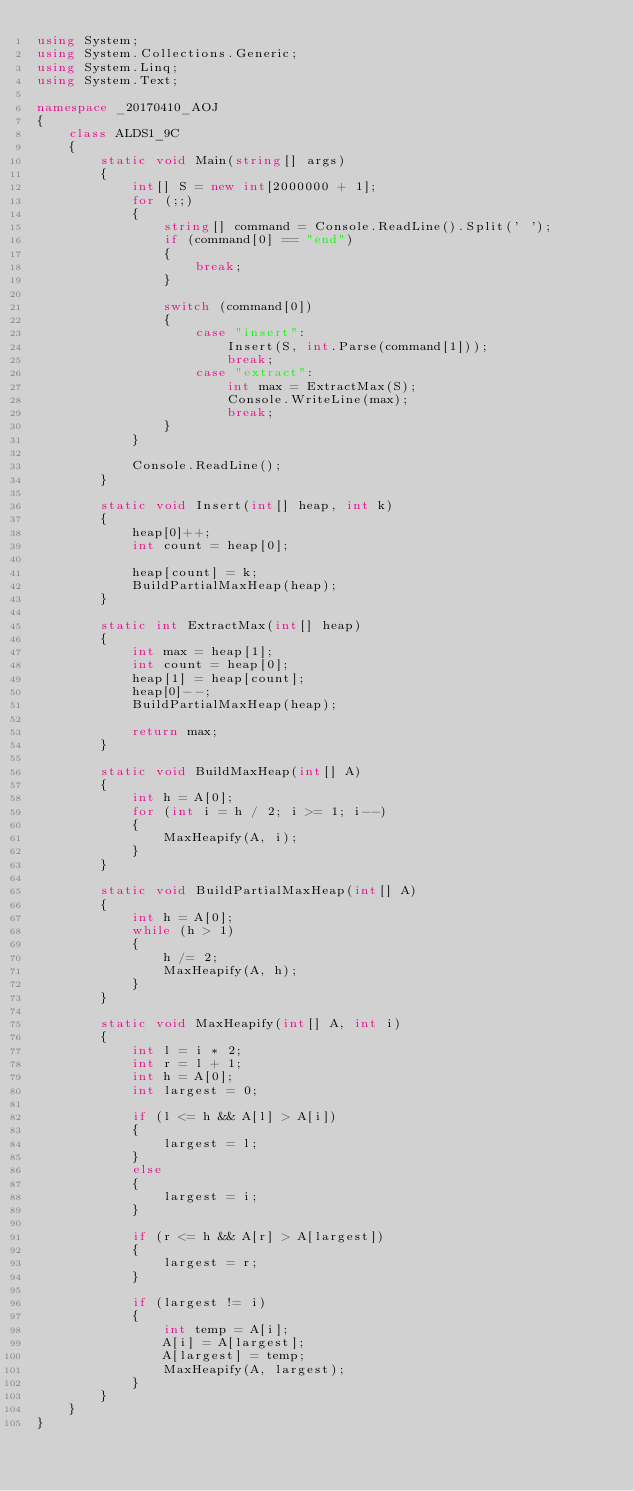Convert code to text. <code><loc_0><loc_0><loc_500><loc_500><_C#_>using System;
using System.Collections.Generic;
using System.Linq;
using System.Text;

namespace _20170410_AOJ
{
    class ALDS1_9C
    {
        static void Main(string[] args)
        {
            int[] S = new int[2000000 + 1];
            for (;;)
            {
                string[] command = Console.ReadLine().Split(' ');
                if (command[0] == "end")
                {
                    break;
                }

                switch (command[0])
                {
                    case "insert":
                        Insert(S, int.Parse(command[1]));
                        break;
                    case "extract":
                        int max = ExtractMax(S);
                        Console.WriteLine(max);
                        break;
                }
            }
            
            Console.ReadLine();
        }

        static void Insert(int[] heap, int k)
        {
            heap[0]++;
            int count = heap[0];

            heap[count] = k;
            BuildPartialMaxHeap(heap);
        }

        static int ExtractMax(int[] heap)
        {
            int max = heap[1];
            int count = heap[0];
            heap[1] = heap[count];
            heap[0]--;
            BuildPartialMaxHeap(heap);

            return max;
        }

        static void BuildMaxHeap(int[] A)
        {
            int h = A[0];
            for (int i = h / 2; i >= 1; i--)
            {
                MaxHeapify(A, i);
            }
        }

        static void BuildPartialMaxHeap(int[] A)
        {
            int h = A[0];
            while (h > 1)
            {
                h /= 2;
                MaxHeapify(A, h);
            }
        }

        static void MaxHeapify(int[] A, int i)
        {
            int l = i * 2;
            int r = l + 1;
            int h = A[0];
            int largest = 0;

            if (l <= h && A[l] > A[i])
            {
                largest = l;
            }
            else
            {
                largest = i;
            }

            if (r <= h && A[r] > A[largest])
            {
                largest = r;
            }

            if (largest != i)
            {
                int temp = A[i];
                A[i] = A[largest];
                A[largest] = temp;
                MaxHeapify(A, largest);
            }
        }
    }
}

</code> 